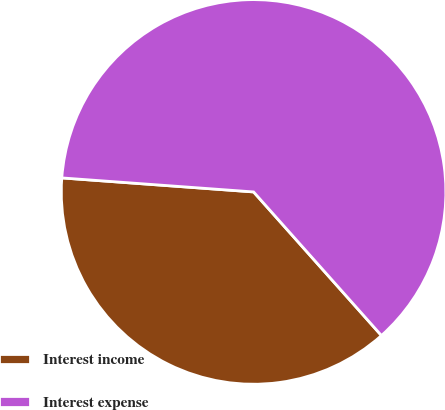Convert chart to OTSL. <chart><loc_0><loc_0><loc_500><loc_500><pie_chart><fcel>Interest income<fcel>Interest expense<nl><fcel>37.74%<fcel>62.26%<nl></chart> 